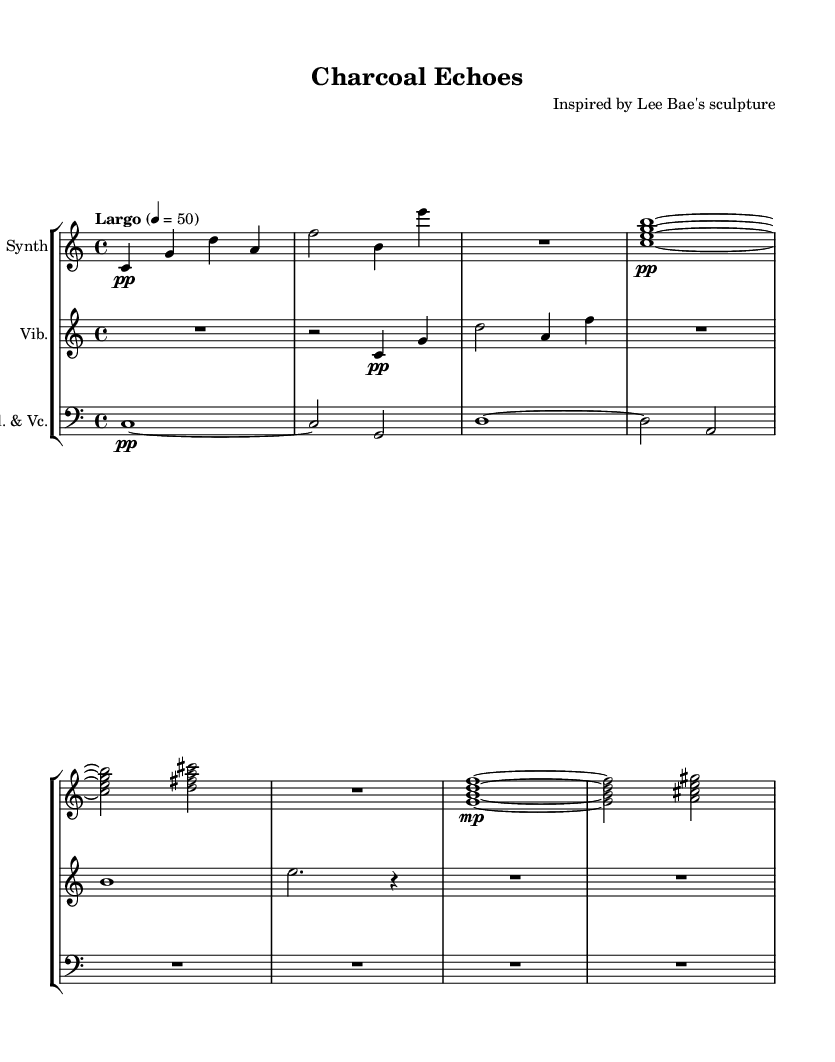What is the time signature of this music? The time signature is indicated at the beginning of the score, which shows that there are four beats per measure, represented by 4/4.
Answer: 4/4 What is the tempo marking for this piece? The tempo marking is found at the beginning after the time signature, indicating "Largo," which suggests a slow pace.
Answer: Largo How many instruments are included in this composition? The score shows three staves, each labeled with a different instrument, which means there are three instruments: Synth, Vibraphone, and Bass Clarinet with Cello.
Answer: Three What dynamic marking is used for the synthesizer's first note? The first note for the synthesizer has a "pp" marking, indicating a very soft dynamic for that note.
Answer: pp What is the clef used for the vibraphone? The vibraphone is written in the treble clef, as indicated at the beginning of its staff.
Answer: Treble Explain the relationship between the synthesizer and the bass clarinet and cello in terms of function. The synthesizer plays higher melodic lines while both the bass clarinet and cello provide a harmonic foundation; this division illustrates a common texture in ambient music, where the synth evokes space and the bass instruments add depth.
Answer: Harmonic foundation 